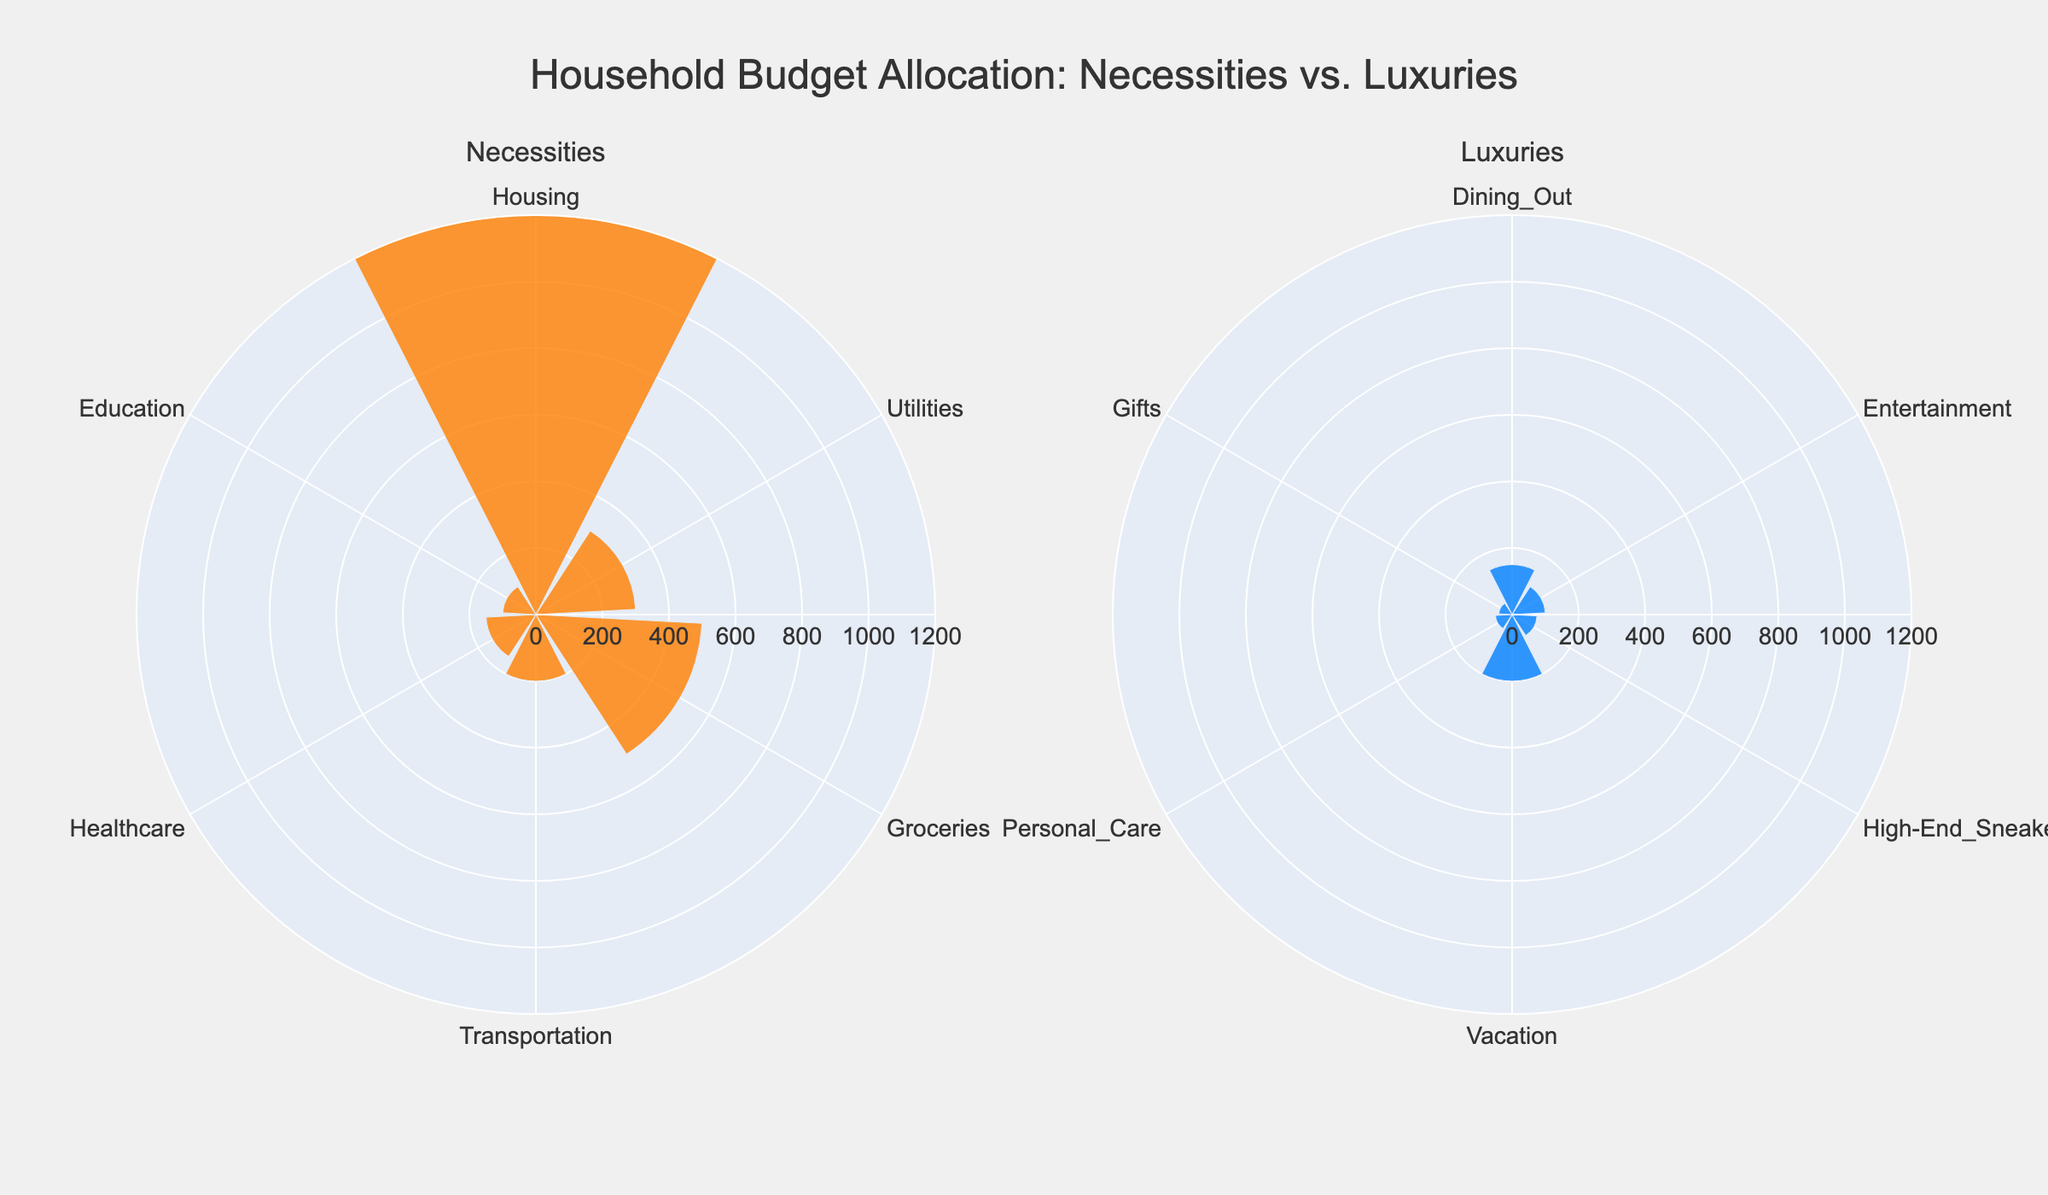What is the total monthly expenditure on necessities? To find the total monthly expenditure on necessities, sum up the expenditures listed under the necessities category: 1200 (Housing) + 300 (Utilities) + 500 (Groceries) + 200 (Transportation) + 150 (Healthcare) + 100 (Education). The total is 2450.
Answer: 2450 Which category has the highest monthly expenditure within the luxuries? Identify the highest monthly expenditure value within the luxuries category. The expenditures are: Dining Out (150), Entertainment (100), High-End Sneakers (75), Vacation (200), Personal Care (50), Gifts (40). Vacation has the highest expenditure at 200.
Answer: Vacation By how much does the expenditure on housing exceed the expenditure on high-end sneakers? Subtract the expenditure on high-end sneakers from the expenditure on housing. Housing is 1200 and high-end sneakers are 75: 1200 - 75 = 1125.
Answer: 1125 What is the total monthly expenditure on luxuries? Sum up the expenditures listed under the luxuries category: 150 (Dining Out) + 100 (Entertainment) + 75 (High-End Sneakers) + 200 (Vacation) + 50 (Personal Care) + 40 (Gifts). The total is 615.
Answer: 615 Which necessity has the lowest monthly expenditure? Identify the lowest monthly expenditure value within the necessities category. The expenditures are: Housing (1200), Utilities (300), Groceries (500), Transportation (200), Healthcare (150), Education (100). Education has the lowest expenditure at 100.
Answer: Education How does the monthly expenditure on groceries compare to the monthly expenditure on vacation? Compare the expenditures for groceries (500) and vacation (200). Groceries is higher than vacation. 500 (Groceries) is greater than 200 (Vacation).
Answer: Groceries is higher What percentage of the total necessities expenditure is spent on healthcare? Divide the expenditure on healthcare by the total expenditure on necessities, then multiply by 100 to get the percentage. Healthcare is 150 and total necessities expenditure is 2450. (150 / 2450) * 100 = 6.12%.
Answer: 6.12% Considering the total budget for both necessities and luxuries, what fraction is spent on high-end sneakers alone? First, find the total budget for both necessities and luxuries: 2450 (necessities) + 615 (luxuries) = 3065. Then, divide the expenditure on high-end sneakers by this total: 75 / 3065.
Answer: Approximately 1/41 Is there a category in luxuries that has a monthly expenditure equal to any category in necessities? Compare each luxuries expenditure to each necessities expenditure to find any equal values. None of the luxuries values (150, 100, 75, 200, 50, 40) match exactly with the necessities values (1200, 300, 500, 200, 150, 100).
Answer: No 